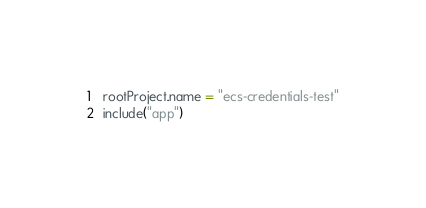Convert code to text. <code><loc_0><loc_0><loc_500><loc_500><_Kotlin_>rootProject.name = "ecs-credentials-test"
include("app")
</code> 